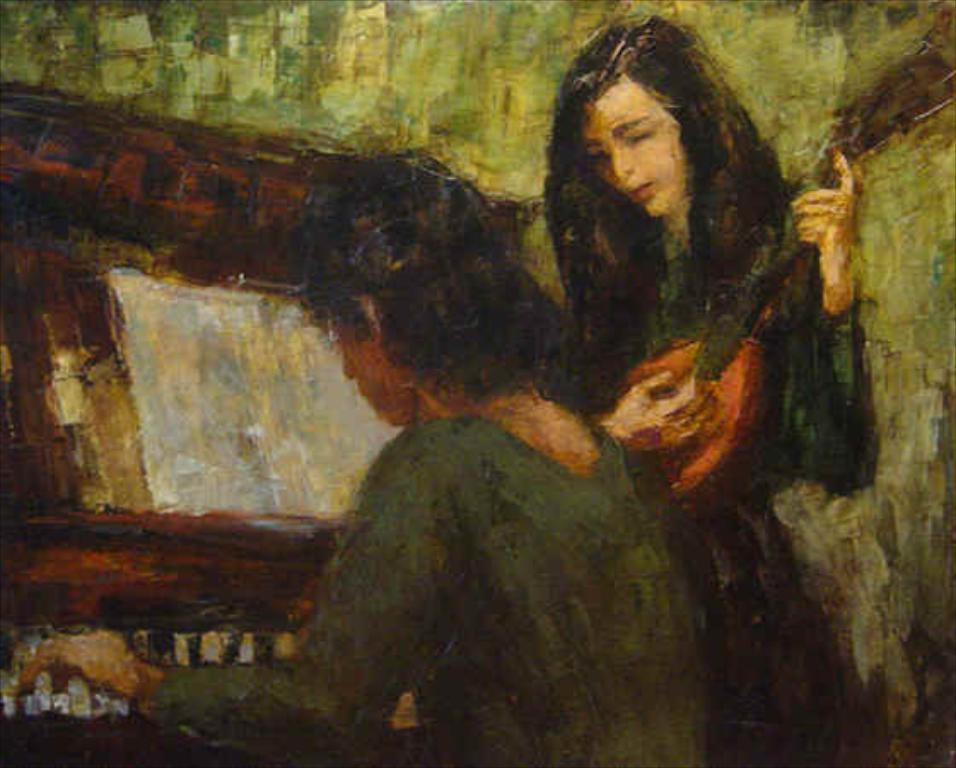How many people are in the image? There are two women in the image. What are the women doing in the image? One woman is playing the guitar, and the other woman is playing the piano. What color is the wall in the background of the image? The wall in the background of the image is green. What type of adjustment does the piano need in the image? There is no indication in the image that the piano needs any adjustment. What thought is the woman playing the guitar having while performing? We cannot determine the thoughts of the woman playing the guitar from the image alone. 